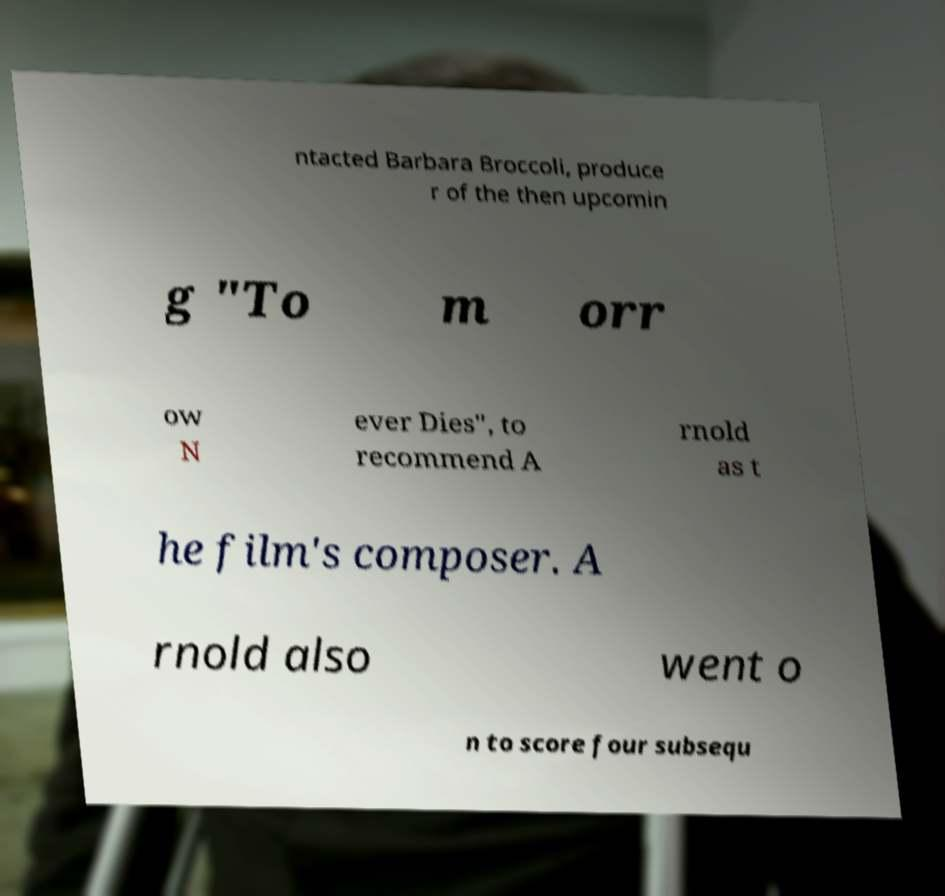Could you extract and type out the text from this image? ntacted Barbara Broccoli, produce r of the then upcomin g "To m orr ow N ever Dies", to recommend A rnold as t he film's composer. A rnold also went o n to score four subsequ 